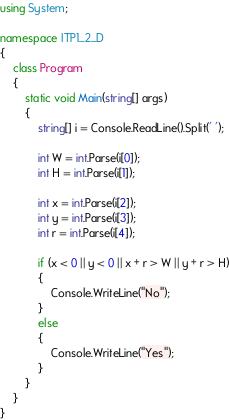Convert code to text. <code><loc_0><loc_0><loc_500><loc_500><_C#_>using System;

namespace ITP1_2_D
{
    class Program
    {
        static void Main(string[] args)
        {
            string[] i = Console.ReadLine().Split(' ');

            int W = int.Parse(i[0]);
            int H = int.Parse(i[1]);

            int x = int.Parse(i[2]);
            int y = int.Parse(i[3]);
            int r = int.Parse(i[4]);

            if (x < 0 || y < 0 || x + r > W || y + r > H)
            {
                Console.WriteLine("No");
            }
            else
            {
                Console.WriteLine("Yes");
            }
        }
    }
}

</code> 